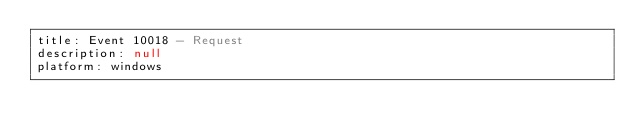<code> <loc_0><loc_0><loc_500><loc_500><_YAML_>title: Event 10018 - Request
description: null
platform: windows</code> 